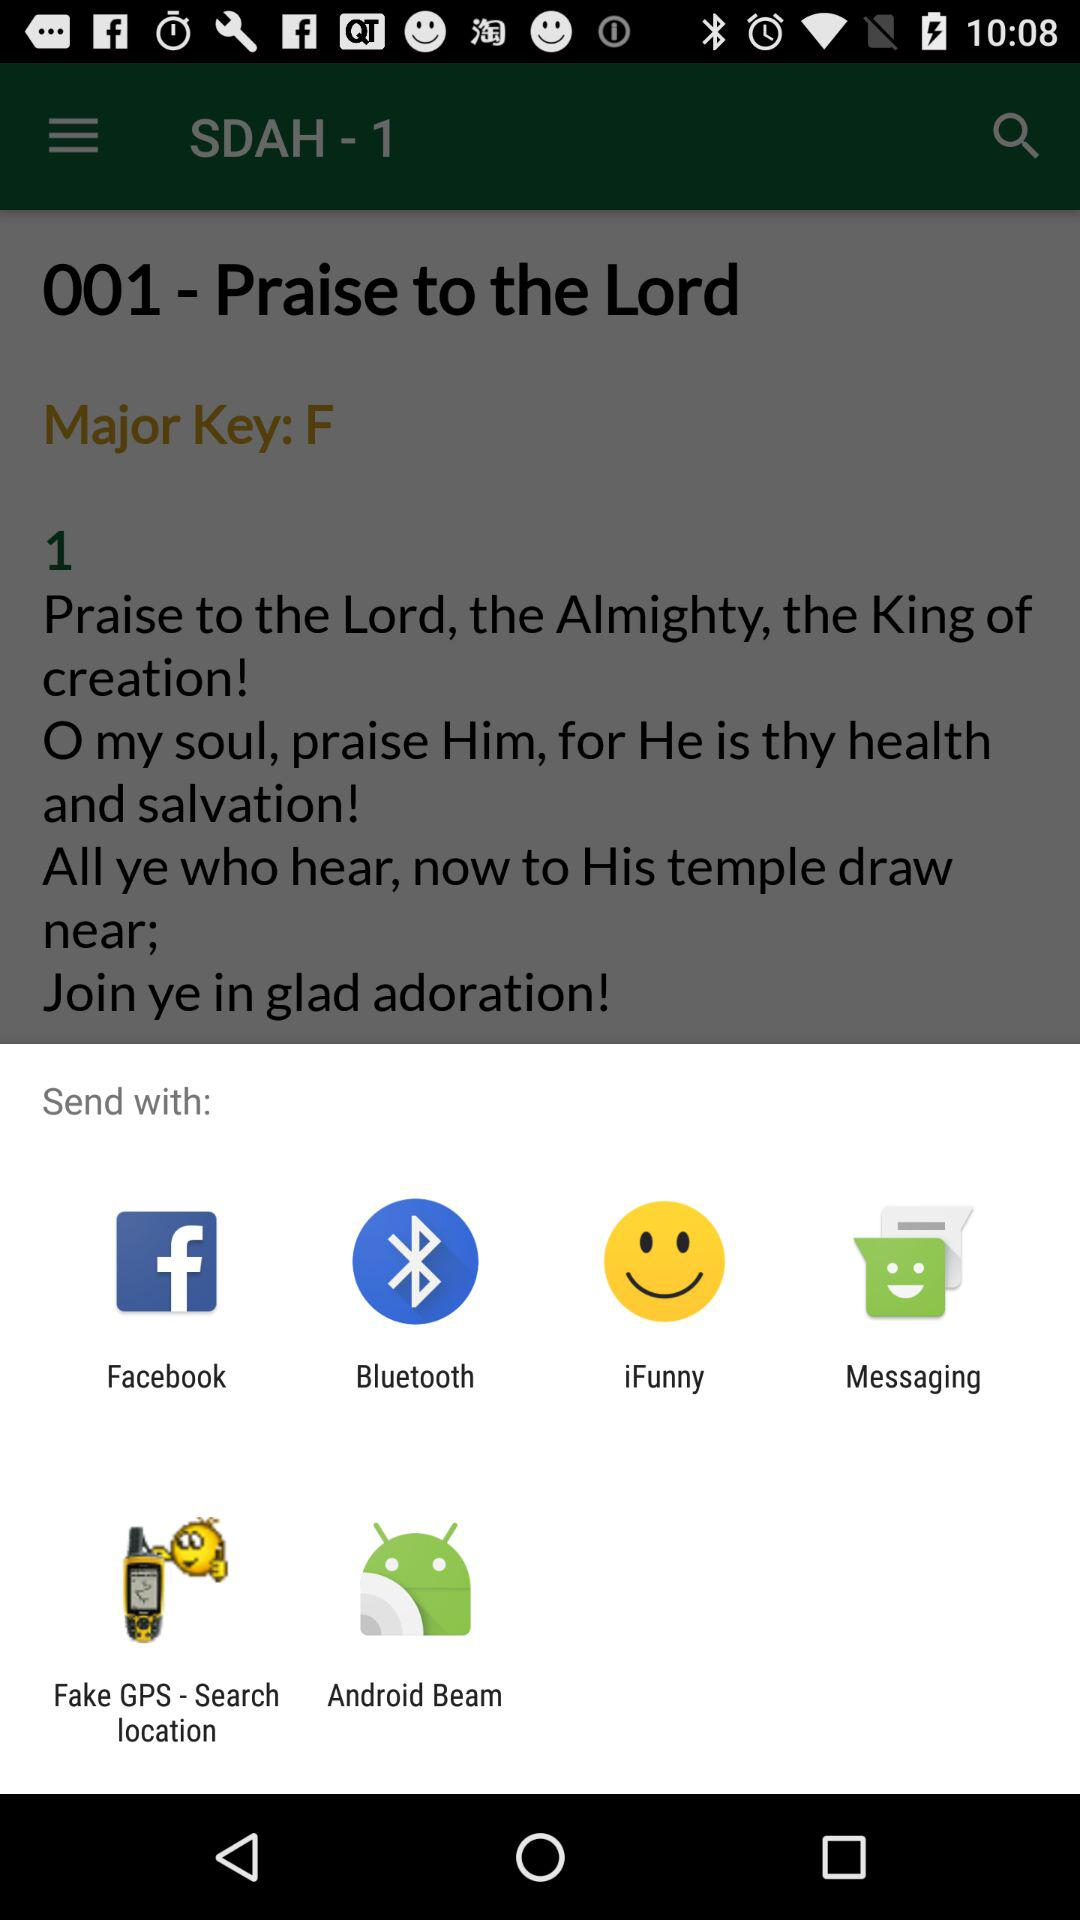What are the sharing options available on the screen? The available options are "Facebook", "Bluetooth", "iFunny", "Messaging", "Fake GPS - Search location" and "Android Beam". 